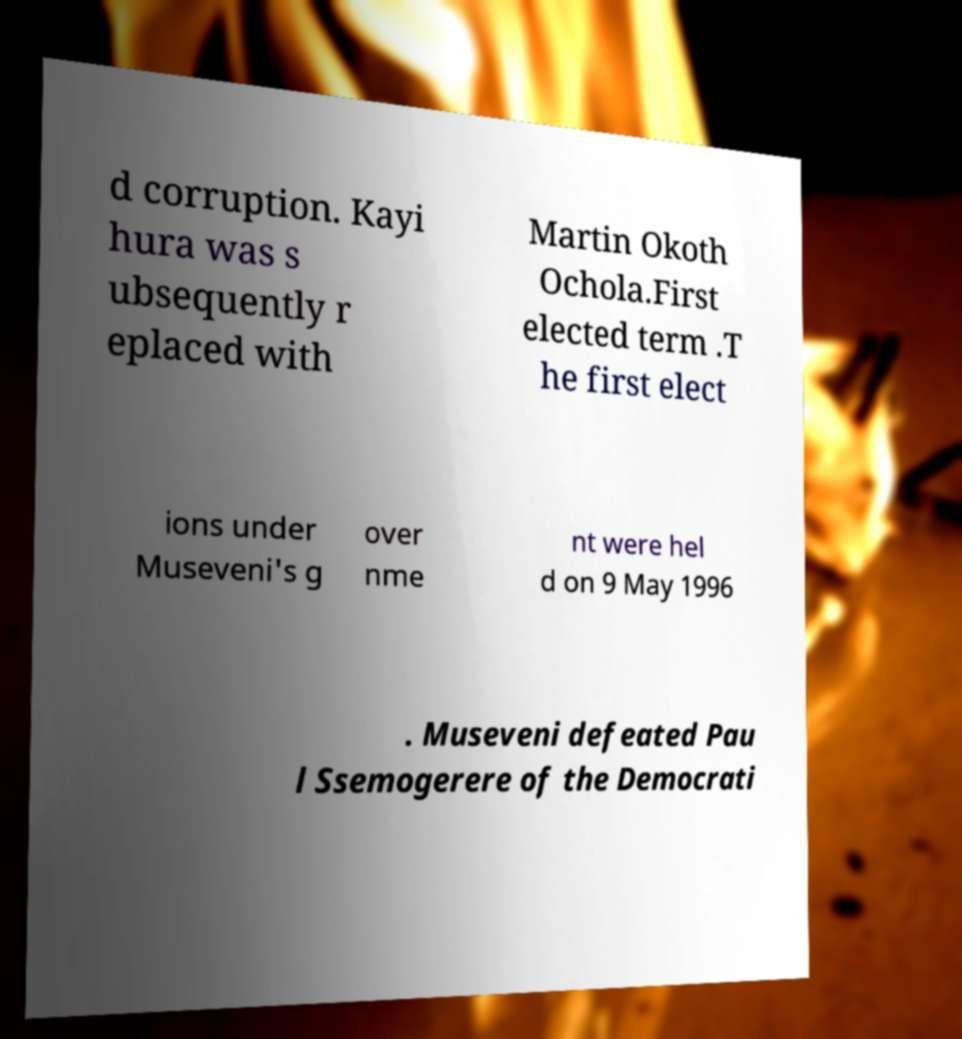Please read and relay the text visible in this image. What does it say? d corruption. Kayi hura was s ubsequently r eplaced with Martin Okoth Ochola.First elected term .T he first elect ions under Museveni's g over nme nt were hel d on 9 May 1996 . Museveni defeated Pau l Ssemogerere of the Democrati 